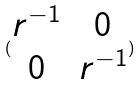<formula> <loc_0><loc_0><loc_500><loc_500>( \begin{matrix} r ^ { - 1 } & 0 \\ 0 & r ^ { - 1 } \end{matrix} )</formula> 